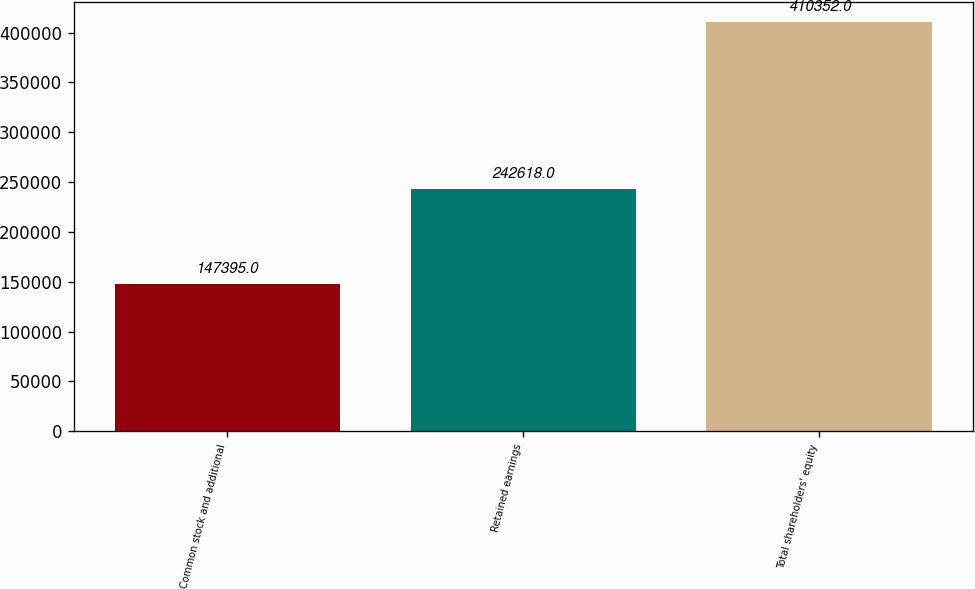Convert chart. <chart><loc_0><loc_0><loc_500><loc_500><bar_chart><fcel>Common stock and additional<fcel>Retained earnings<fcel>Total shareholders' equity<nl><fcel>147395<fcel>242618<fcel>410352<nl></chart> 